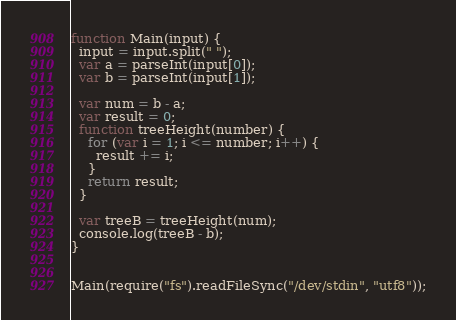<code> <loc_0><loc_0><loc_500><loc_500><_JavaScript_>function Main(input) {
  input = input.split(" ");
  var a = parseInt(input[0]);
  var b = parseInt(input[1]);

  var num = b - a;
  var result = 0;
  function treeHeight(number) {
    for (var i = 1; i <= number; i++) {
      result += i;
    }
    return result;
  }

  var treeB = treeHeight(num);
  console.log(treeB - b);
}


Main(require("fs").readFileSync("/dev/stdin", "utf8"));
</code> 